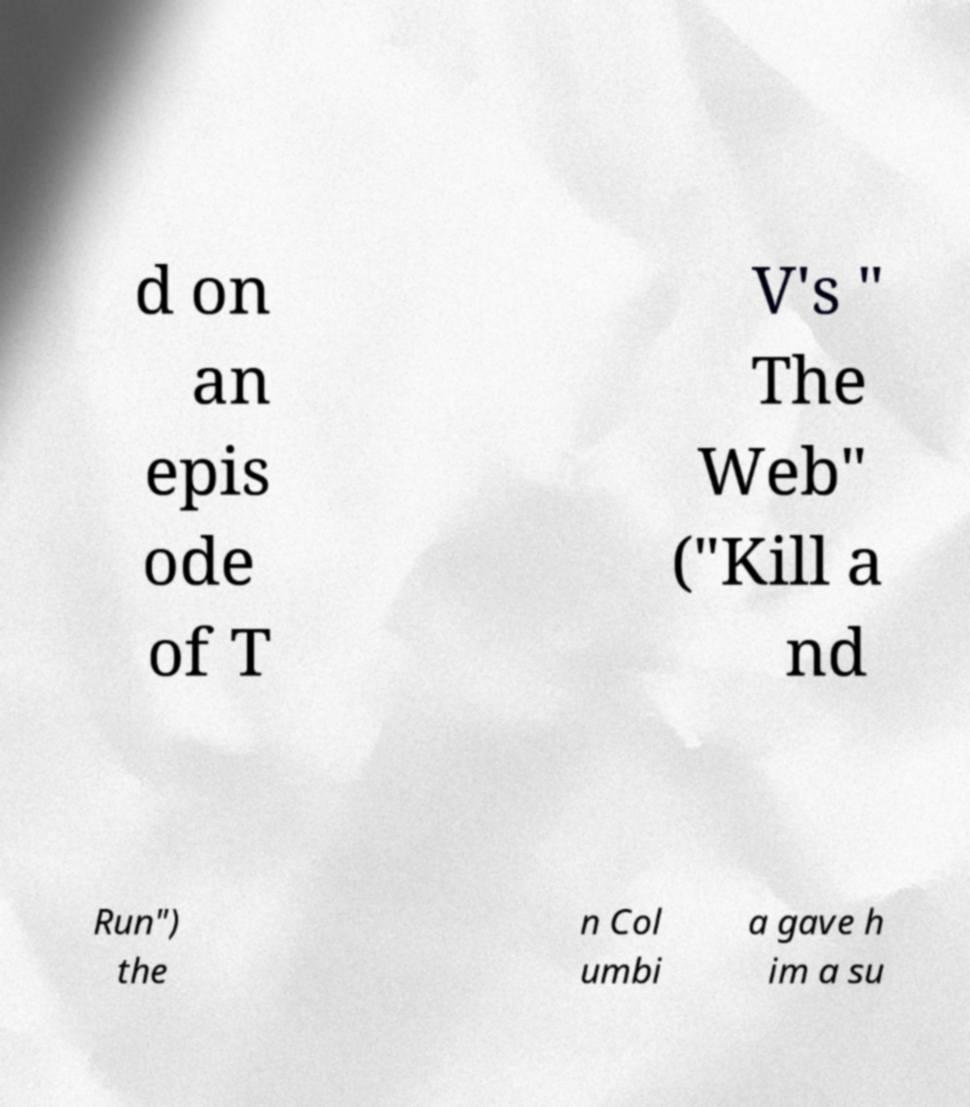Please read and relay the text visible in this image. What does it say? d on an epis ode of T V's " The Web" ("Kill a nd Run") the n Col umbi a gave h im a su 